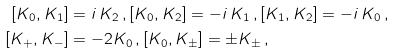Convert formula to latex. <formula><loc_0><loc_0><loc_500><loc_500>[ K _ { 0 } , K _ { 1 } ] & = i \, K _ { 2 } \, , [ K _ { 0 } , K _ { 2 } ] = - i \, K _ { 1 } \, , [ K _ { 1 } , K _ { 2 } ] = - i \, K _ { 0 } \, , \\ [ K _ { + } , K _ { - } ] & = - 2 K _ { 0 } \, , [ K _ { 0 } , K _ { \pm } ] = \pm K _ { \pm } \, ,</formula> 